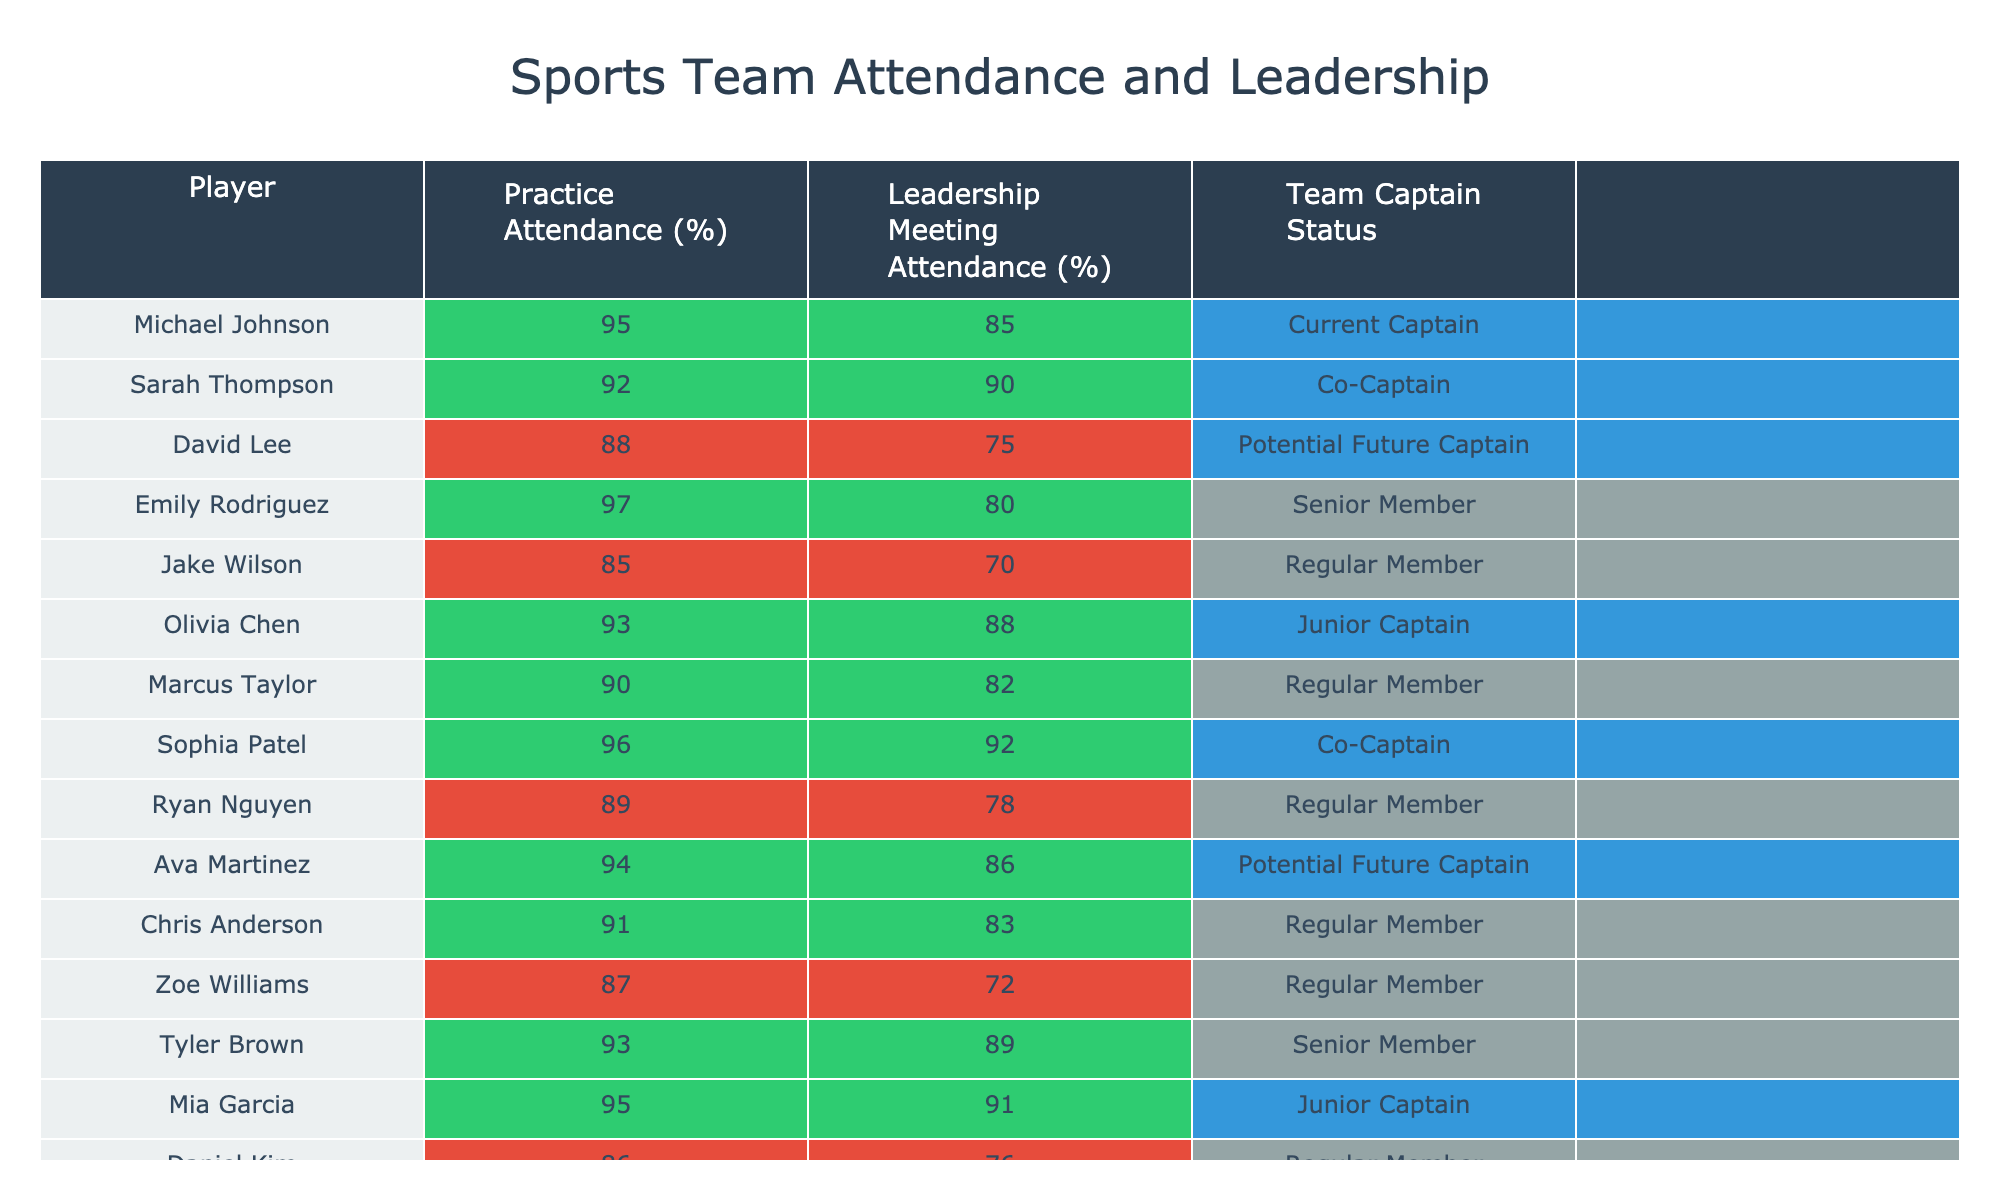What is the highest practice attendance percentage recorded? By examining the "Practice Attendance (%)" column, we can see that Michael Johnson has the highest percentage at 95%.
Answer: 95% What is the average leadership meeting attendance percentage for all players? To find the average, add all the percentages (85 + 90 + 75 + 80 + 70 + 88 + 82 + 92 + 78 + 86 + 83 + 72 + 89 + 91 + 76) which equals 1278, then divide by 15 players giving 1278/15 = 85.2.
Answer: 85.2% Which player has the lowest leadership meeting attendance percentage? Looking at the "Leadership Meeting Attendance (%)" column, Jake Wilson has the lowest attendance at 70%.
Answer: 70% Do all players with a practice attendance percentage above 90% also have a leadership meeting attendance above 80%? Checking the players with practice attendance above 90%: Michael Johnson, Sarah Thompson, Emily Rodriguez, Olivia Chen, Sophia Patel, Ava Martinez, Mia Garcia, Tyler Brown. Out of these, only Emily Rodriguez (80%) does not meet the criteria, making the statement false.
Answer: No How many players are currently team captains? The "Team Captain Status" column indicates that Michael Johnson and Sophia Patel (2) are the only current captains.
Answer: 2 Is there a player with a perfect attendance in both categories? Reviewing the table, no player has a 100% attendance in either practice or leadership meetings. Thus, the statement is false.
Answer: No What is the difference in attendance percentage between the highest and lowest practice attendance? The highest practice attendance is 97% (Emily Rodriguez) and the lowest is 85% (Jake Wilson), so the difference is 97 - 85 = 12%.
Answer: 12% Which player with potential future captain status has the highest practice attendance percentage? Among the players with potential future captain status, David Lee has 88% and Ava Martinez has 94%. Since 94% is higher, it's Ava Martinez.
Answer: Ava Martinez What percentage of players have regular member status? There are 6 regular members (Jake Wilson, Marcus Taylor, Ryan Nguyen, Chris Anderson, Daniel Kim) out of 15 players. Thus, the percentage is (6/15) * 100 = 40%.
Answer: 40% Which player has the same practice and leadership meeting attendance percentage? Reviewing the table, no player has the same percentage in both categories. They all have different values.
Answer: None 